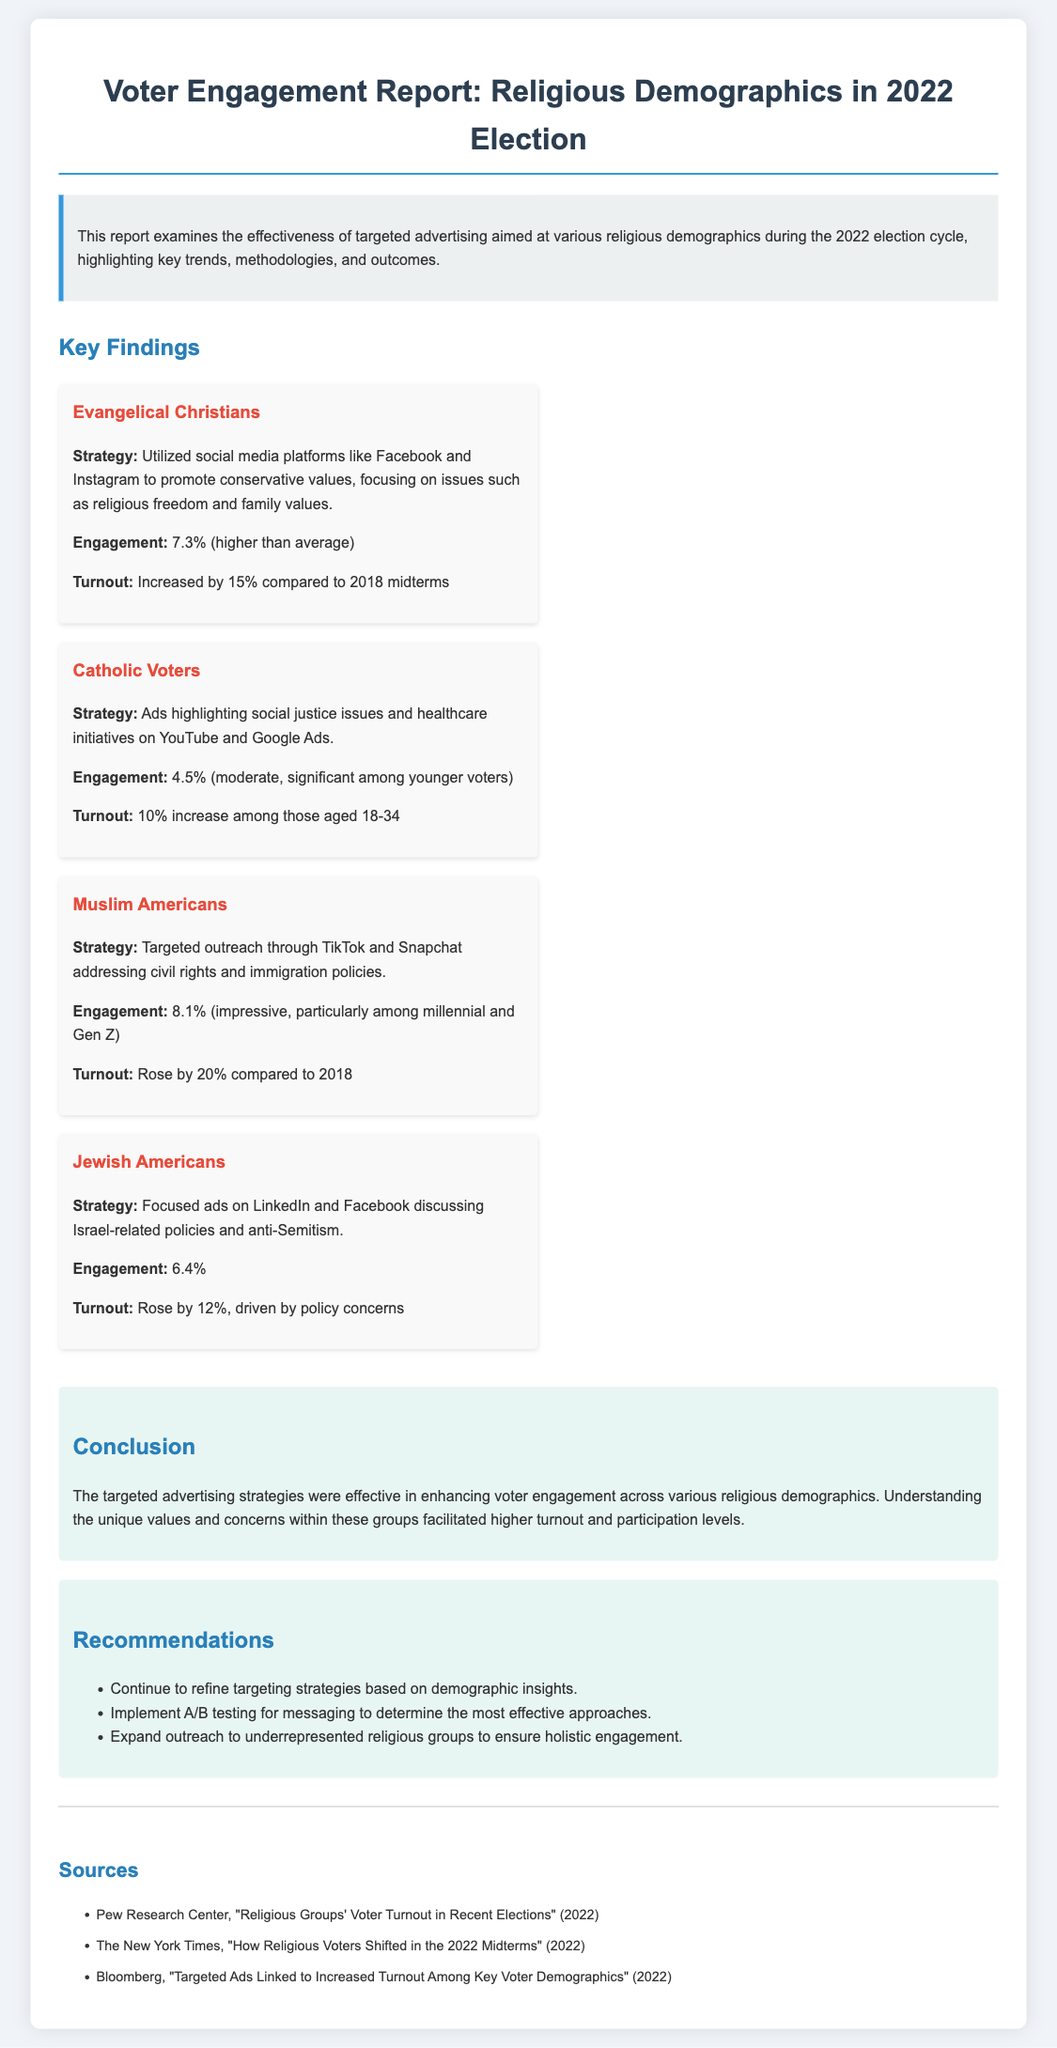What was the engagement rate for Evangelical Christians? The engagement rate for Evangelical Christians is stated in the document as 7.3%, which is higher than average.
Answer: 7.3% What increase in voter turnout did Muslim Americans experience? The document specifies that Muslim Americans had a voter turnout increase of 20% compared to 2018.
Answer: 20% Which social media platforms were used to target Catholic voters? The document mentions that ads highlighted social justice issues and healthcare initiatives on YouTube and Google Ads.
Answer: YouTube and Google Ads What key issue was emphasized in the ads targeted at Jewish Americans? The document points out that the ads centered on discussing Israel-related policies and anti-Semitism.
Answer: Israel-related policies and anti-Semitism What is one recommendation made in the report? The report suggests continuing to refine targeting strategies based on demographic insights.
Answer: Refine targeting strategies based on demographic insights What demographic experienced a 10% increase in turnout among younger voters? The document indicates that Catholic voters saw a 10% increase among those aged 18-34.
Answer: Catholic voters What was the focus of the engagement strategy for Muslim Americans? The document highlights that the engagement strategy focused on civil rights and immigration policies.
Answer: Civil rights and immigration policies Which group had the highest engagement rate? The engagement rate for Muslim Americans was the highest at 8.1%, according to the document.
Answer: 8.1% 